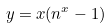<formula> <loc_0><loc_0><loc_500><loc_500>y = x ( n ^ { x } - 1 )</formula> 